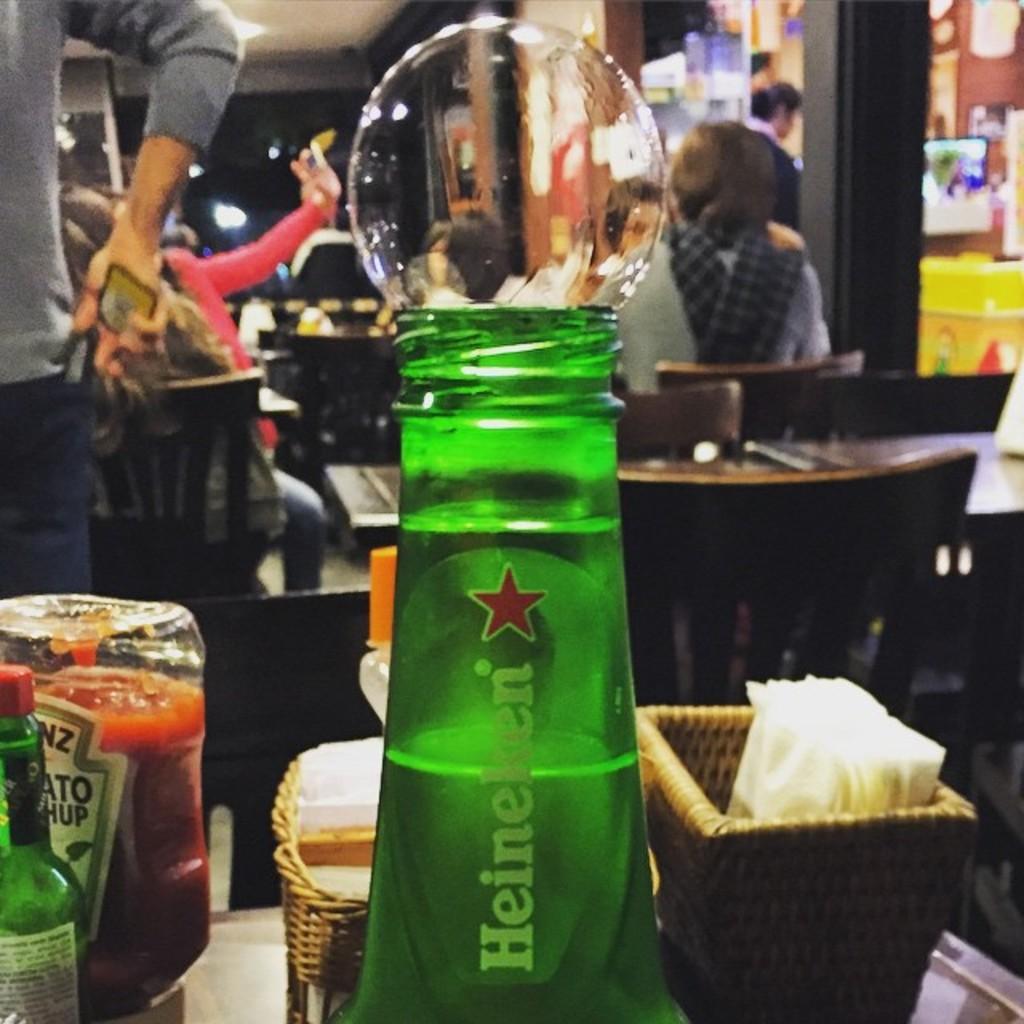How would you summarize this image in a sentence or two? On this table there are bottles, bubble and baskets with tissue. At the background one person is standing and holding a mobile and few persons are sitting on chairs. 